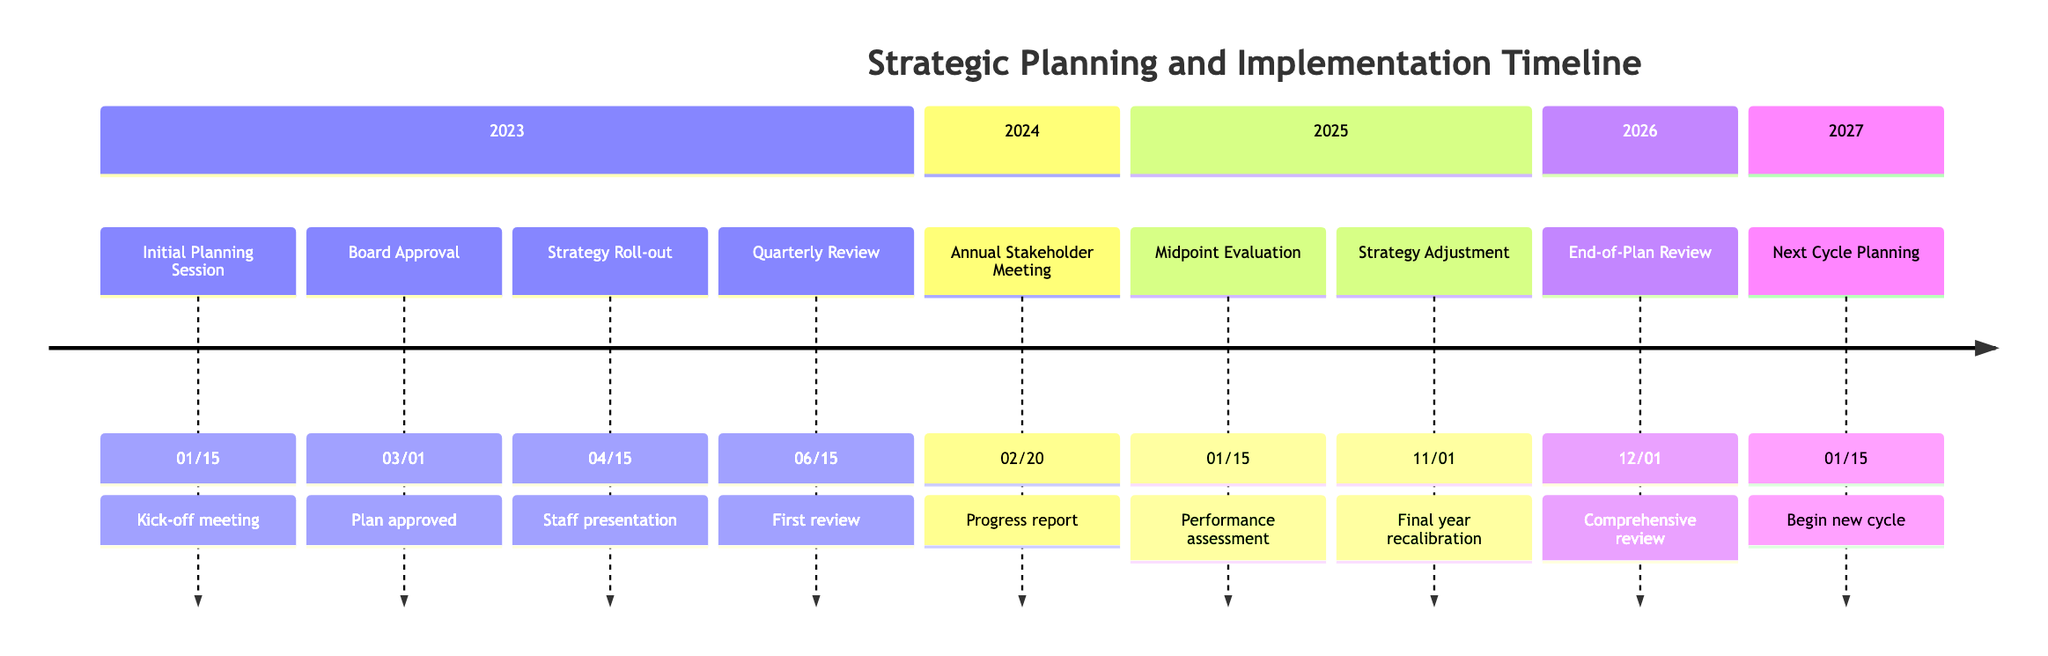What is the date of the Initial Planning Session? The diagram indicates that the Initial Planning Session is scheduled for January 15, 2023.
Answer: January 15, 2023 How many milestones are there in the timeline? By counting the entries in the diagram, there are a total of 9 milestones listed across the timeline.
Answer: 9 What event occurs immediately after the Board Approval? Referring to the timeline, the event that occurs after the Board Approval on March 1, 2023, is the Strategy Roll-out to Staff on April 15, 2023.
Answer: Strategy Roll-out to Staff What is the purpose of the Midpoint Evaluation? The Midpoint Evaluation on January 15, 2025, serves to perform a thorough assessment of performance measures and risk management strategies halfway through the plan.
Answer: Performance assessment Which year features the Annual Stakeholder Meeting? The diagram shows that the Annual Stakeholder Meeting is scheduled for February 20, 2024, occurring in the year 2024.
Answer: 2024 What significant adjustment is made in the final year? The timeline indicates that in the final year, a "Final Year Strategy Adjustment" occurs on November 1, 2025, which involves recalibrating the strategy.
Answer: Final Year Strategy Adjustment What is the date when the End-of-Plan Review takes place? According to the timeline, the End-of-Plan Review is set for December 1, 2026.
Answer: December 1, 2026 When does the planning for the next strategic cycle begin? The diagram states that the Initial Planning for Next Cycle starts on January 15, 2027, following the completion of the current cycle.
Answer: January 15, 2027 